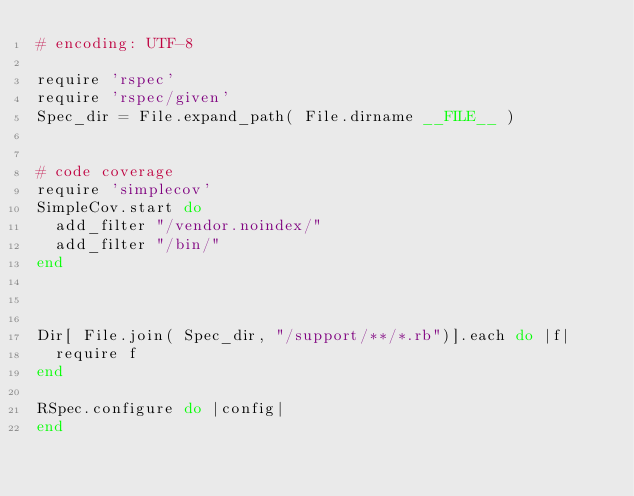Convert code to text. <code><loc_0><loc_0><loc_500><loc_500><_Ruby_># encoding: UTF-8

require 'rspec'
require 'rspec/given'
Spec_dir = File.expand_path( File.dirname __FILE__ )


# code coverage
require 'simplecov'
SimpleCov.start do
  add_filter "/vendor.noindex/"
  add_filter "/bin/"
end



Dir[ File.join( Spec_dir, "/support/**/*.rb")].each do |f| 
  require f
end

RSpec.configure do |config|
end
</code> 